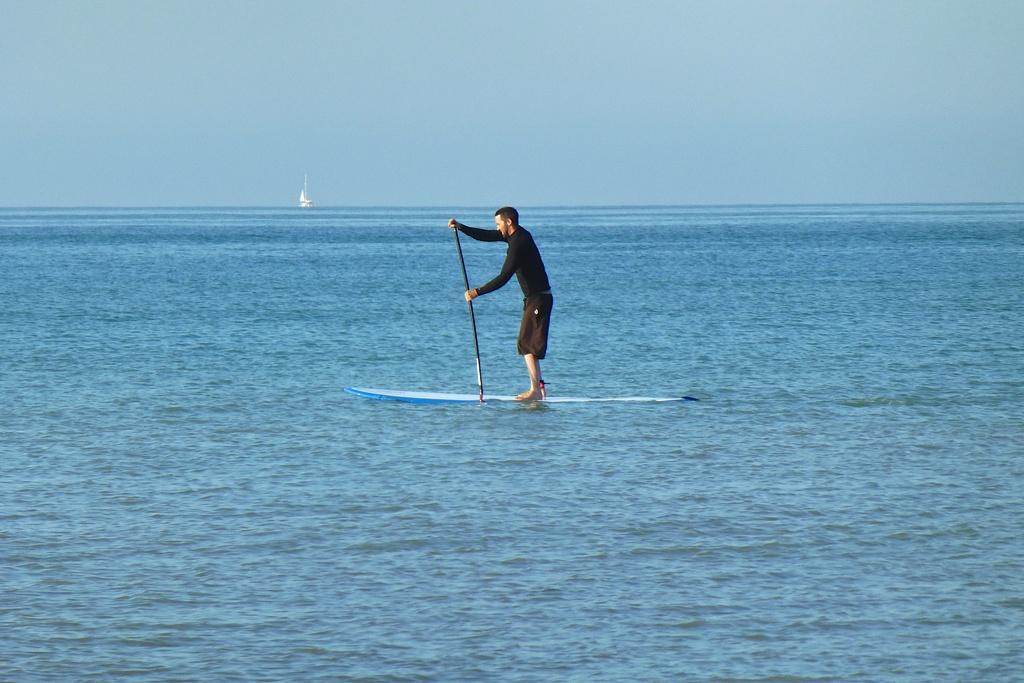What is the main subject of the subject of the image? The main subject of the image is a man. What is the man holding in the image? The man is holding a stick in the image. What is the man standing on in the image? The man is standing on a surfboard in the image. What type of environment is visible in the image? There is water visible in the image, suggesting a water-based setting. What can be seen in the background of the image? There is a white color thing and the sky visible in the background. What type of bread is the man eating in the image? There is no bread present in the image; the man is holding a stick and standing on a surfboard. How many snakes can be seen slithering around the man in the image? There are no snakes present in the image; the man is standing on a surfboard in a water-based setting. 